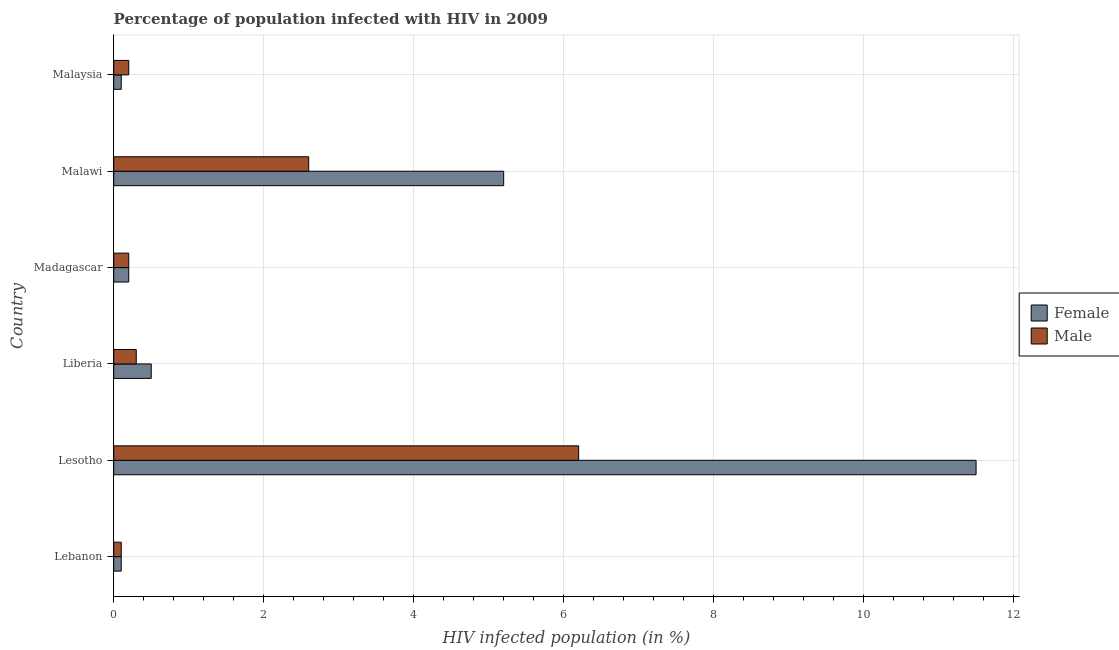How many different coloured bars are there?
Ensure brevity in your answer.  2. How many groups of bars are there?
Offer a terse response. 6. Are the number of bars per tick equal to the number of legend labels?
Your answer should be compact. Yes. How many bars are there on the 5th tick from the bottom?
Your answer should be compact. 2. What is the label of the 6th group of bars from the top?
Your response must be concise. Lebanon. What is the percentage of females who are infected with hiv in Lebanon?
Your response must be concise. 0.1. Across all countries, what is the maximum percentage of males who are infected with hiv?
Offer a terse response. 6.2. Across all countries, what is the minimum percentage of males who are infected with hiv?
Your answer should be very brief. 0.1. In which country was the percentage of females who are infected with hiv maximum?
Provide a succinct answer. Lesotho. In which country was the percentage of males who are infected with hiv minimum?
Keep it short and to the point. Lebanon. What is the difference between the percentage of females who are infected with hiv in Lebanon and the percentage of males who are infected with hiv in Liberia?
Ensure brevity in your answer.  -0.2. What is the ratio of the percentage of males who are infected with hiv in Madagascar to that in Malawi?
Offer a very short reply. 0.08. What is the difference between the highest and the second highest percentage of females who are infected with hiv?
Offer a very short reply. 6.3. What does the 1st bar from the top in Malaysia represents?
Make the answer very short. Male. Are all the bars in the graph horizontal?
Ensure brevity in your answer.  Yes. Are the values on the major ticks of X-axis written in scientific E-notation?
Your answer should be very brief. No. Does the graph contain any zero values?
Your answer should be very brief. No. Does the graph contain grids?
Provide a short and direct response. Yes. How are the legend labels stacked?
Keep it short and to the point. Vertical. What is the title of the graph?
Ensure brevity in your answer.  Percentage of population infected with HIV in 2009. Does "UN agencies" appear as one of the legend labels in the graph?
Keep it short and to the point. No. What is the label or title of the X-axis?
Provide a succinct answer. HIV infected population (in %). What is the HIV infected population (in %) in Female in Lesotho?
Ensure brevity in your answer.  11.5. What is the HIV infected population (in %) of Female in Liberia?
Offer a terse response. 0.5. What is the HIV infected population (in %) in Female in Madagascar?
Offer a terse response. 0.2. What is the HIV infected population (in %) in Male in Madagascar?
Offer a terse response. 0.2. What is the HIV infected population (in %) in Male in Malawi?
Provide a short and direct response. 2.6. What is the HIV infected population (in %) in Female in Malaysia?
Your response must be concise. 0.1. What is the HIV infected population (in %) of Male in Malaysia?
Give a very brief answer. 0.2. Across all countries, what is the maximum HIV infected population (in %) in Female?
Provide a short and direct response. 11.5. Across all countries, what is the minimum HIV infected population (in %) in Male?
Keep it short and to the point. 0.1. What is the total HIV infected population (in %) of Male in the graph?
Provide a short and direct response. 9.6. What is the difference between the HIV infected population (in %) in Female in Lebanon and that in Lesotho?
Offer a terse response. -11.4. What is the difference between the HIV infected population (in %) in Male in Lebanon and that in Lesotho?
Offer a terse response. -6.1. What is the difference between the HIV infected population (in %) of Female in Lebanon and that in Madagascar?
Your answer should be very brief. -0.1. What is the difference between the HIV infected population (in %) in Male in Lebanon and that in Madagascar?
Provide a succinct answer. -0.1. What is the difference between the HIV infected population (in %) in Female in Lebanon and that in Malaysia?
Ensure brevity in your answer.  0. What is the difference between the HIV infected population (in %) of Male in Lebanon and that in Malaysia?
Make the answer very short. -0.1. What is the difference between the HIV infected population (in %) of Female in Lesotho and that in Madagascar?
Ensure brevity in your answer.  11.3. What is the difference between the HIV infected population (in %) in Female in Lesotho and that in Malawi?
Offer a terse response. 6.3. What is the difference between the HIV infected population (in %) in Female in Lesotho and that in Malaysia?
Give a very brief answer. 11.4. What is the difference between the HIV infected population (in %) of Female in Liberia and that in Malawi?
Keep it short and to the point. -4.7. What is the difference between the HIV infected population (in %) of Male in Liberia and that in Malawi?
Provide a succinct answer. -2.3. What is the difference between the HIV infected population (in %) in Female in Liberia and that in Malaysia?
Keep it short and to the point. 0.4. What is the difference between the HIV infected population (in %) in Female in Madagascar and that in Malawi?
Your answer should be very brief. -5. What is the difference between the HIV infected population (in %) in Male in Madagascar and that in Malawi?
Give a very brief answer. -2.4. What is the difference between the HIV infected population (in %) of Female in Madagascar and that in Malaysia?
Give a very brief answer. 0.1. What is the difference between the HIV infected population (in %) in Male in Madagascar and that in Malaysia?
Offer a terse response. 0. What is the difference between the HIV infected population (in %) in Female in Lebanon and the HIV infected population (in %) in Male in Madagascar?
Keep it short and to the point. -0.1. What is the difference between the HIV infected population (in %) of Female in Lebanon and the HIV infected population (in %) of Male in Malawi?
Offer a very short reply. -2.5. What is the difference between the HIV infected population (in %) in Female in Lebanon and the HIV infected population (in %) in Male in Malaysia?
Your answer should be very brief. -0.1. What is the difference between the HIV infected population (in %) of Female in Lesotho and the HIV infected population (in %) of Male in Liberia?
Offer a terse response. 11.2. What is the difference between the HIV infected population (in %) of Female in Madagascar and the HIV infected population (in %) of Male in Malaysia?
Offer a terse response. 0. What is the difference between the HIV infected population (in %) of Female in Malawi and the HIV infected population (in %) of Male in Malaysia?
Offer a terse response. 5. What is the average HIV infected population (in %) in Female per country?
Keep it short and to the point. 2.93. What is the average HIV infected population (in %) of Male per country?
Give a very brief answer. 1.6. What is the difference between the HIV infected population (in %) in Female and HIV infected population (in %) in Male in Lebanon?
Give a very brief answer. 0. What is the difference between the HIV infected population (in %) in Female and HIV infected population (in %) in Male in Lesotho?
Offer a very short reply. 5.3. What is the difference between the HIV infected population (in %) of Female and HIV infected population (in %) of Male in Madagascar?
Give a very brief answer. 0. What is the difference between the HIV infected population (in %) in Female and HIV infected population (in %) in Male in Malawi?
Offer a terse response. 2.6. What is the ratio of the HIV infected population (in %) of Female in Lebanon to that in Lesotho?
Ensure brevity in your answer.  0.01. What is the ratio of the HIV infected population (in %) of Male in Lebanon to that in Lesotho?
Make the answer very short. 0.02. What is the ratio of the HIV infected population (in %) of Female in Lebanon to that in Liberia?
Your answer should be compact. 0.2. What is the ratio of the HIV infected population (in %) of Female in Lebanon to that in Madagascar?
Offer a terse response. 0.5. What is the ratio of the HIV infected population (in %) in Female in Lebanon to that in Malawi?
Your answer should be very brief. 0.02. What is the ratio of the HIV infected population (in %) of Male in Lebanon to that in Malawi?
Provide a succinct answer. 0.04. What is the ratio of the HIV infected population (in %) of Female in Lebanon to that in Malaysia?
Provide a succinct answer. 1. What is the ratio of the HIV infected population (in %) in Male in Lesotho to that in Liberia?
Your response must be concise. 20.67. What is the ratio of the HIV infected population (in %) in Female in Lesotho to that in Madagascar?
Make the answer very short. 57.5. What is the ratio of the HIV infected population (in %) in Male in Lesotho to that in Madagascar?
Your response must be concise. 31. What is the ratio of the HIV infected population (in %) of Female in Lesotho to that in Malawi?
Offer a very short reply. 2.21. What is the ratio of the HIV infected population (in %) of Male in Lesotho to that in Malawi?
Your answer should be very brief. 2.38. What is the ratio of the HIV infected population (in %) in Female in Lesotho to that in Malaysia?
Your answer should be compact. 115. What is the ratio of the HIV infected population (in %) in Male in Lesotho to that in Malaysia?
Provide a succinct answer. 31. What is the ratio of the HIV infected population (in %) of Female in Liberia to that in Madagascar?
Make the answer very short. 2.5. What is the ratio of the HIV infected population (in %) of Male in Liberia to that in Madagascar?
Provide a succinct answer. 1.5. What is the ratio of the HIV infected population (in %) in Female in Liberia to that in Malawi?
Offer a very short reply. 0.1. What is the ratio of the HIV infected population (in %) of Male in Liberia to that in Malawi?
Make the answer very short. 0.12. What is the ratio of the HIV infected population (in %) of Male in Liberia to that in Malaysia?
Your response must be concise. 1.5. What is the ratio of the HIV infected population (in %) in Female in Madagascar to that in Malawi?
Your answer should be very brief. 0.04. What is the ratio of the HIV infected population (in %) in Male in Madagascar to that in Malawi?
Ensure brevity in your answer.  0.08. What is the ratio of the HIV infected population (in %) of Male in Madagascar to that in Malaysia?
Your response must be concise. 1. What is the difference between the highest and the second highest HIV infected population (in %) in Female?
Offer a terse response. 6.3. What is the difference between the highest and the second highest HIV infected population (in %) in Male?
Give a very brief answer. 3.6. 